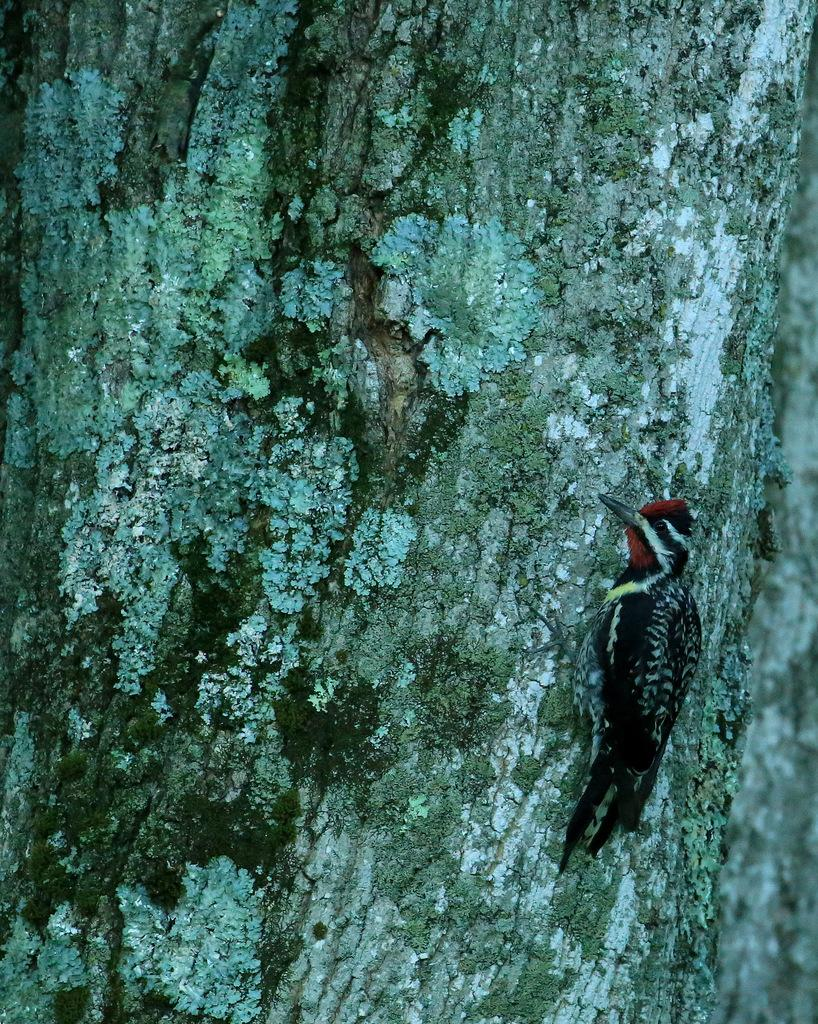What type of bird can be seen in the image? There is a black color bird in the image. Where is the bird located? The bird is standing on a branch of a tree. What is the color of the background in the image? The background of the image is gray in color. What type of marble is the bird holding in its beak in the image? There is no marble present in the image; the bird is standing on a branch of a tree. 